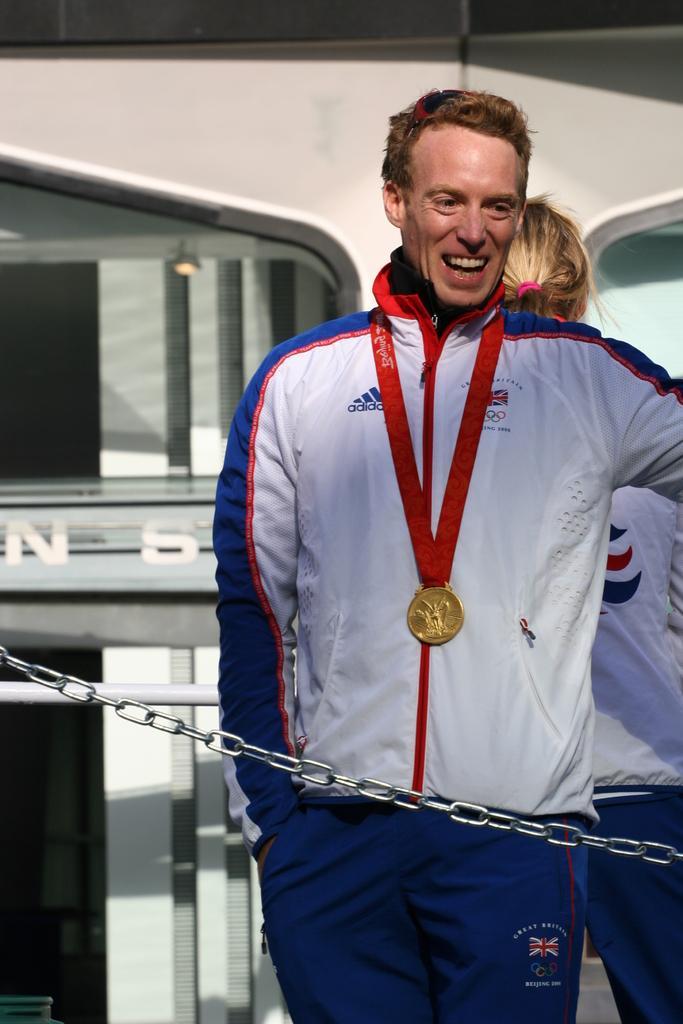Describe this image in one or two sentences. In this image, there is a person wearing a medal and standing in front of the chain. There is an another person on the right side of the image standing and wearing clothes. 